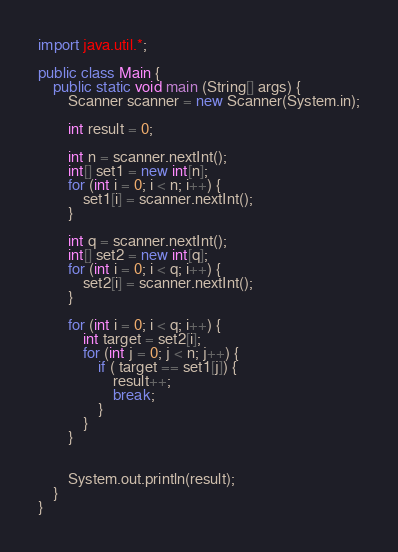<code> <loc_0><loc_0><loc_500><loc_500><_Java_>import java.util.*;

public class Main {
    public static void main (String[] args) {
        Scanner scanner = new Scanner(System.in);

        int result = 0;

        int n = scanner.nextInt();
        int[] set1 = new int[n];
        for (int i = 0; i < n; i++) {
            set1[i] = scanner.nextInt();
        }
        
        int q = scanner.nextInt();
        int[] set2 = new int[q];  
        for (int i = 0; i < q; i++) {
            set2[i] = scanner.nextInt();
        }
        
        for (int i = 0; i < q; i++) {
            int target = set2[i];
            for (int j = 0; j < n; j++) {
                if ( target == set1[j]) {
                    result++;
                    break;
                }
            }
        }

     
        System.out.println(result);
    }
}</code> 